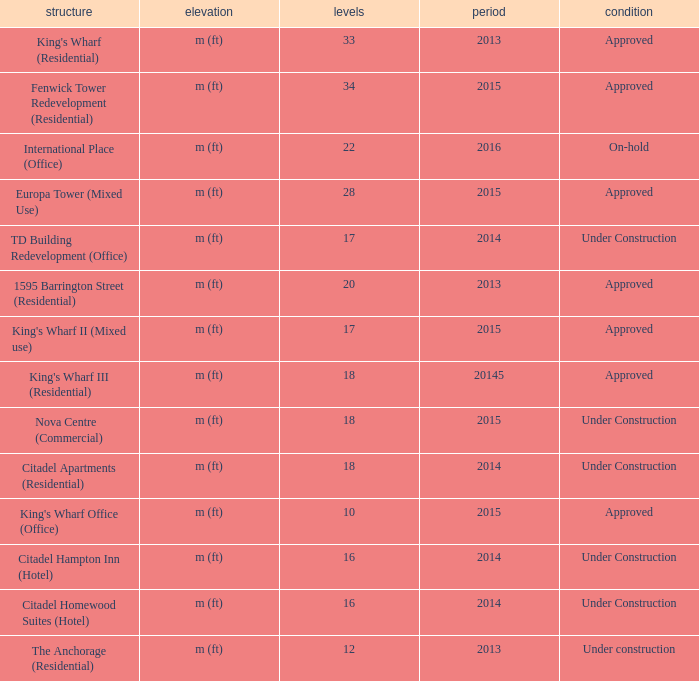What is the status of the building with less than 18 floors and later than 2013? Under Construction, Approved, Approved, Under Construction, Under Construction. 